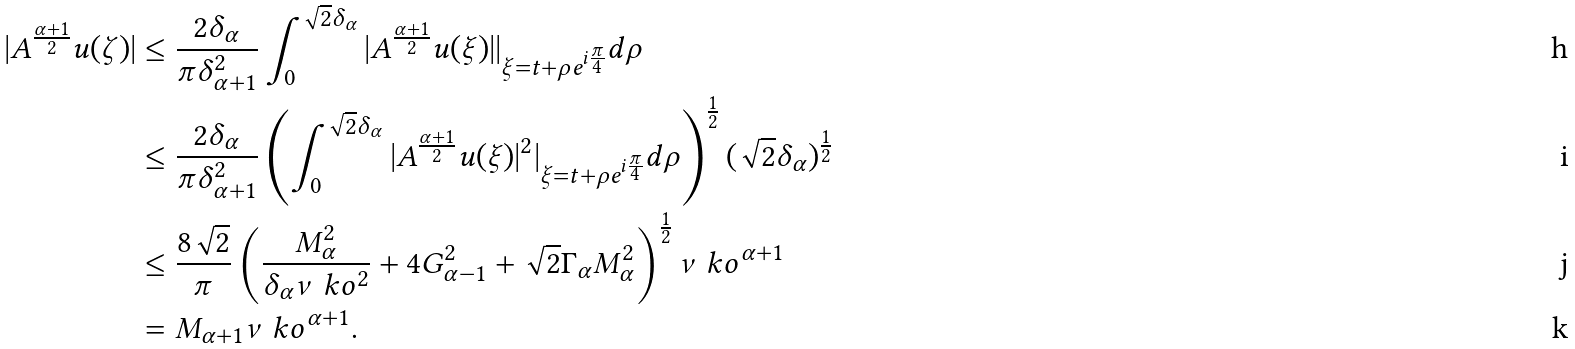Convert formula to latex. <formula><loc_0><loc_0><loc_500><loc_500>| A ^ { \frac { \alpha + 1 } { 2 } } u ( \zeta ) | & \leq \frac { 2 \delta _ { \alpha } } { \pi \delta ^ { 2 } _ { \alpha + 1 } } \int _ { 0 } ^ { \sqrt { 2 } \delta _ { \alpha } } | A ^ { \frac { \alpha + 1 } { 2 } } u ( \xi ) | | _ { \xi = t + \rho e ^ { i \frac { \pi } { 4 } } } d \rho \\ & \leq \frac { 2 \delta _ { \alpha } } { \pi \delta ^ { 2 } _ { \alpha + 1 } } \left ( \int _ { 0 } ^ { \sqrt { 2 } \delta _ { \alpha } } | A ^ { \frac { \alpha + 1 } { 2 } } u ( \xi ) | ^ { 2 } | _ { \xi = t + \rho e ^ { i \frac { \pi } { 4 } } } d \rho \right ) ^ { \frac { 1 } { 2 } } ( \sqrt { 2 } \delta _ { \alpha } ) ^ { \frac { 1 } { 2 } } \\ & \leq \frac { 8 \sqrt { 2 } } { \pi } \left ( \frac { M _ { \alpha } ^ { 2 } } { \delta _ { \alpha } \nu \ k o ^ { 2 } } + 4 G ^ { 2 } _ { \alpha - 1 } + \sqrt { 2 } \Gamma _ { \alpha } M ^ { 2 } _ { \alpha } \right ) ^ { \frac { 1 } { 2 } } \nu \ k o ^ { \alpha + 1 } \\ & = M _ { \alpha + 1 } \nu \ k o ^ { \alpha + 1 } .</formula> 